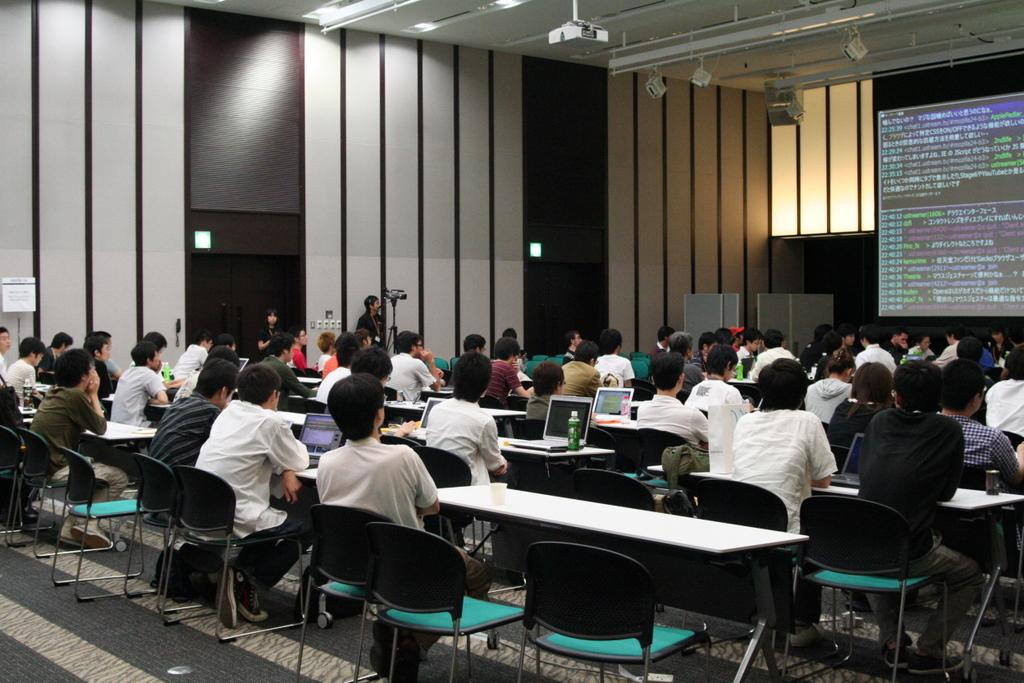How many people are in the image? There is a group of people in the image. What are the people doing in the image? The people are sitting on chairs. What is on the table in front of the people? There is a laptop and bottles on the table. What can be seen in the background of the image? There is a wall and a screen in the background of the image. What type of humor is being displayed on the screen in the background? There is no humor displayed on the screen in the background; it is not mentioned in the facts provided. 